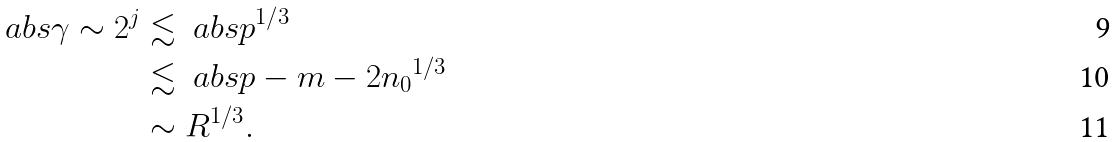Convert formula to latex. <formula><loc_0><loc_0><loc_500><loc_500>\ a b s { \gamma } \sim 2 ^ { j } & \lesssim \ a b s { p } ^ { 1 / 3 } \\ & \lesssim \ a b s { p - m - 2 n _ { 0 } } ^ { 1 / 3 } \\ & \sim R ^ { 1 / 3 } .</formula> 